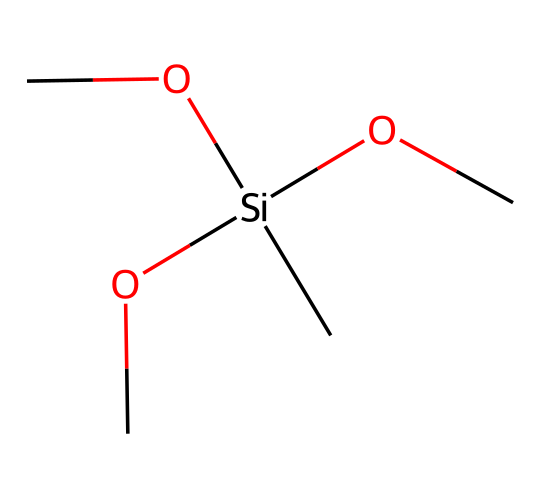How many silicon atoms are present? The chemical structure has one silicon atom represented by the '[Si]' in the SMILES notation. This indicates that there is only one silicon atom in the molecule.
Answer: one What functional groups are present in this structure? The structure contains three methoxy groups (represented by 'OC') attached to the silicon atom. Each 'OC' indicates a methoxy group.
Answer: methoxy groups What is the total number of carbon atoms in the molecule? There are three methoxy groups ('OC') and one additional carbon atom (from 'C' at the end), leading to a total of four carbon atoms when counted: three from the groups and one standalone.
Answer: four What type of compound is represented by this chemical? This chemical is classified as a silane due to the presence of silicon bonded to organic groups. The presence of only silicon and carbon with oxygen indicates it's a silane derivative.
Answer: silane How many total bonds does the silicon atom form? Silicon in this structure forms four bonds: three with the methoxy groups (OC) and one with the hydrocarbon (C). Counting the attached moieties gives a total of four bonds around the silicon atom.
Answer: four Why is this silane likely used in waterproofing? The presence of the three methoxy groups contributes to an increase in hydrophobic characteristics, making it effective as a waterproofing agent by repelling water.
Answer: hydrophobic characteristics 